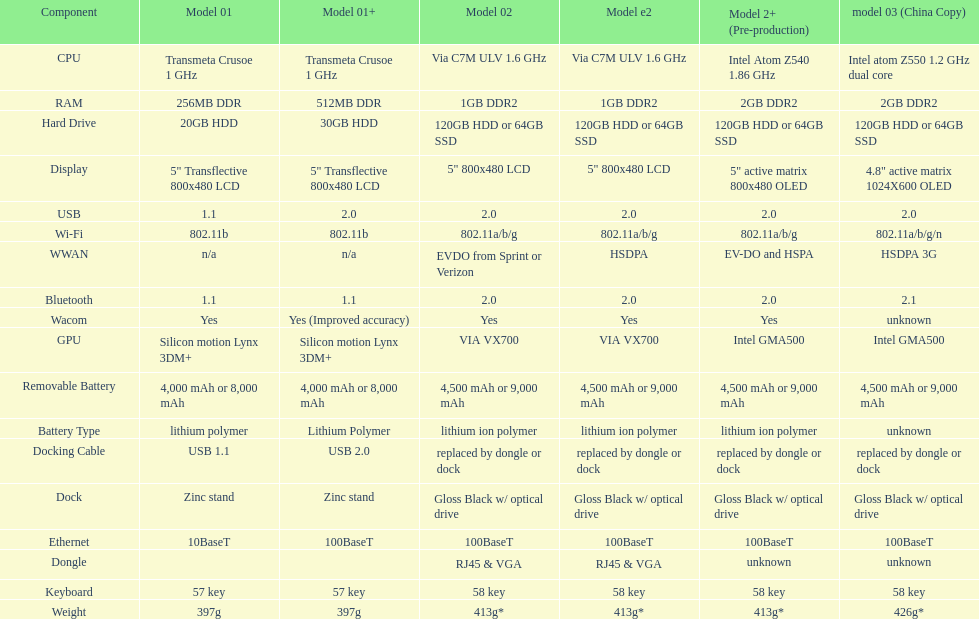How many models have 1.6ghz? 2. 